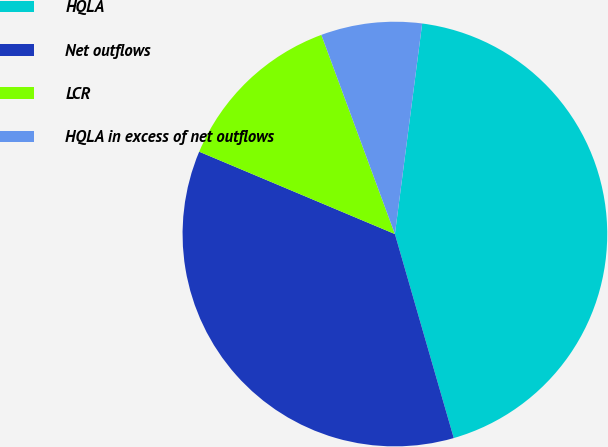Convert chart to OTSL. <chart><loc_0><loc_0><loc_500><loc_500><pie_chart><fcel>HQLA<fcel>Net outflows<fcel>LCR<fcel>HQLA in excess of net outflows<nl><fcel>43.48%<fcel>35.81%<fcel>13.03%<fcel>7.68%<nl></chart> 